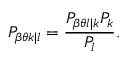<formula> <loc_0><loc_0><loc_500><loc_500>P _ { \beta \theta k | l } = \frac { P _ { \beta \theta l | k } P _ { k } } { P _ { l } } .</formula> 